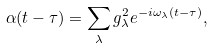Convert formula to latex. <formula><loc_0><loc_0><loc_500><loc_500>\alpha ( t - \tau ) = \sum _ { \lambda } g _ { \lambda } ^ { 2 } e ^ { - i \omega _ { \lambda } ( t - \tau ) } ,</formula> 